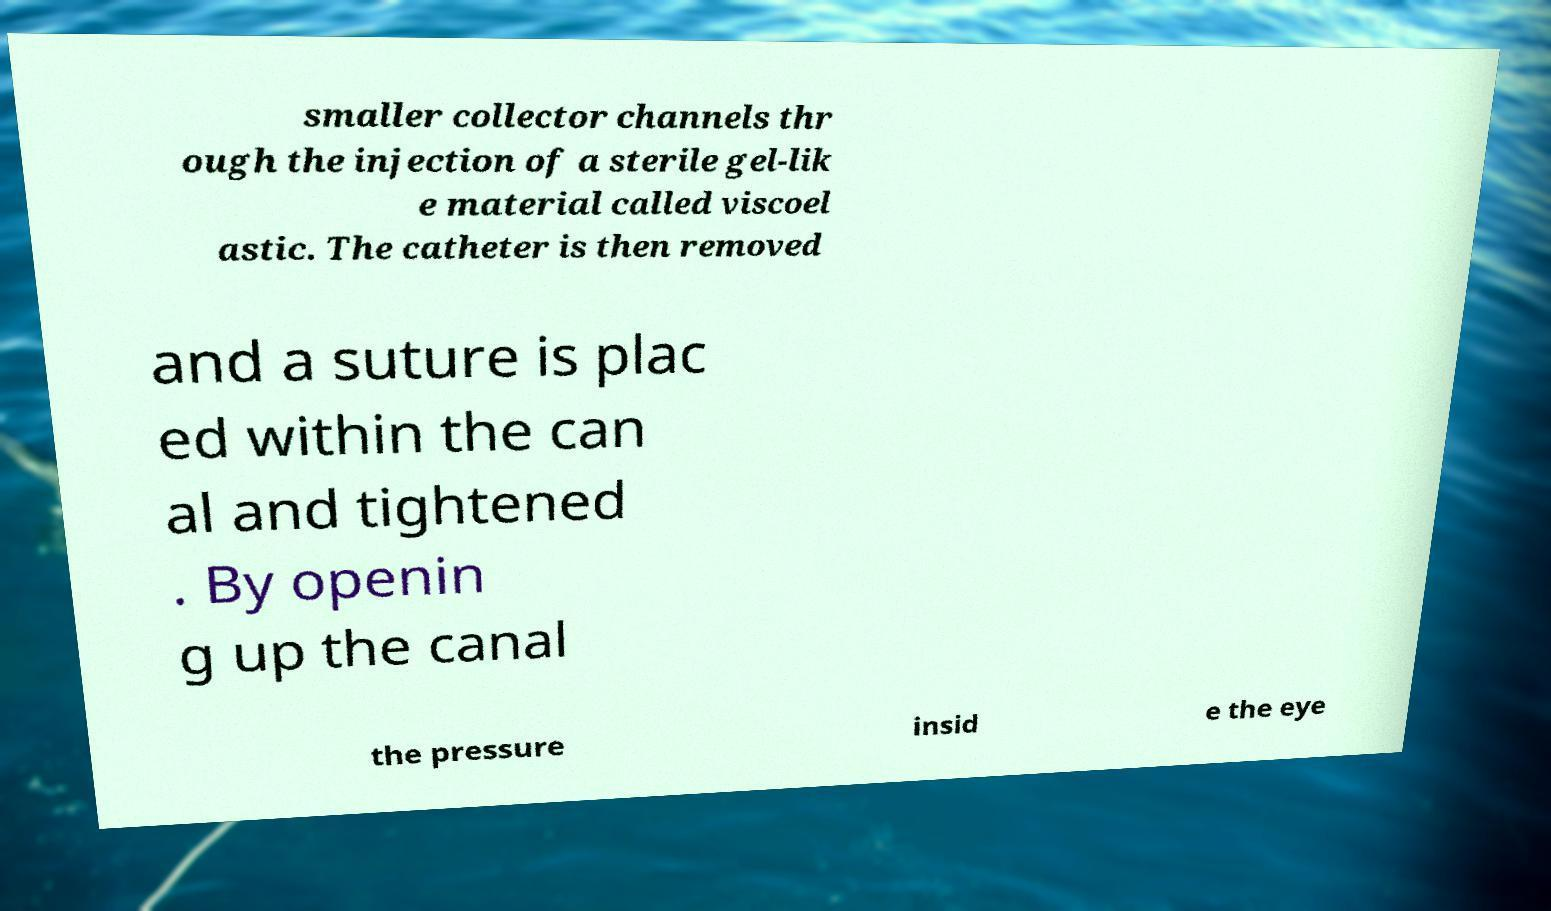For documentation purposes, I need the text within this image transcribed. Could you provide that? smaller collector channels thr ough the injection of a sterile gel-lik e material called viscoel astic. The catheter is then removed and a suture is plac ed within the can al and tightened . By openin g up the canal the pressure insid e the eye 